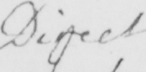What does this handwritten line say? Direct 